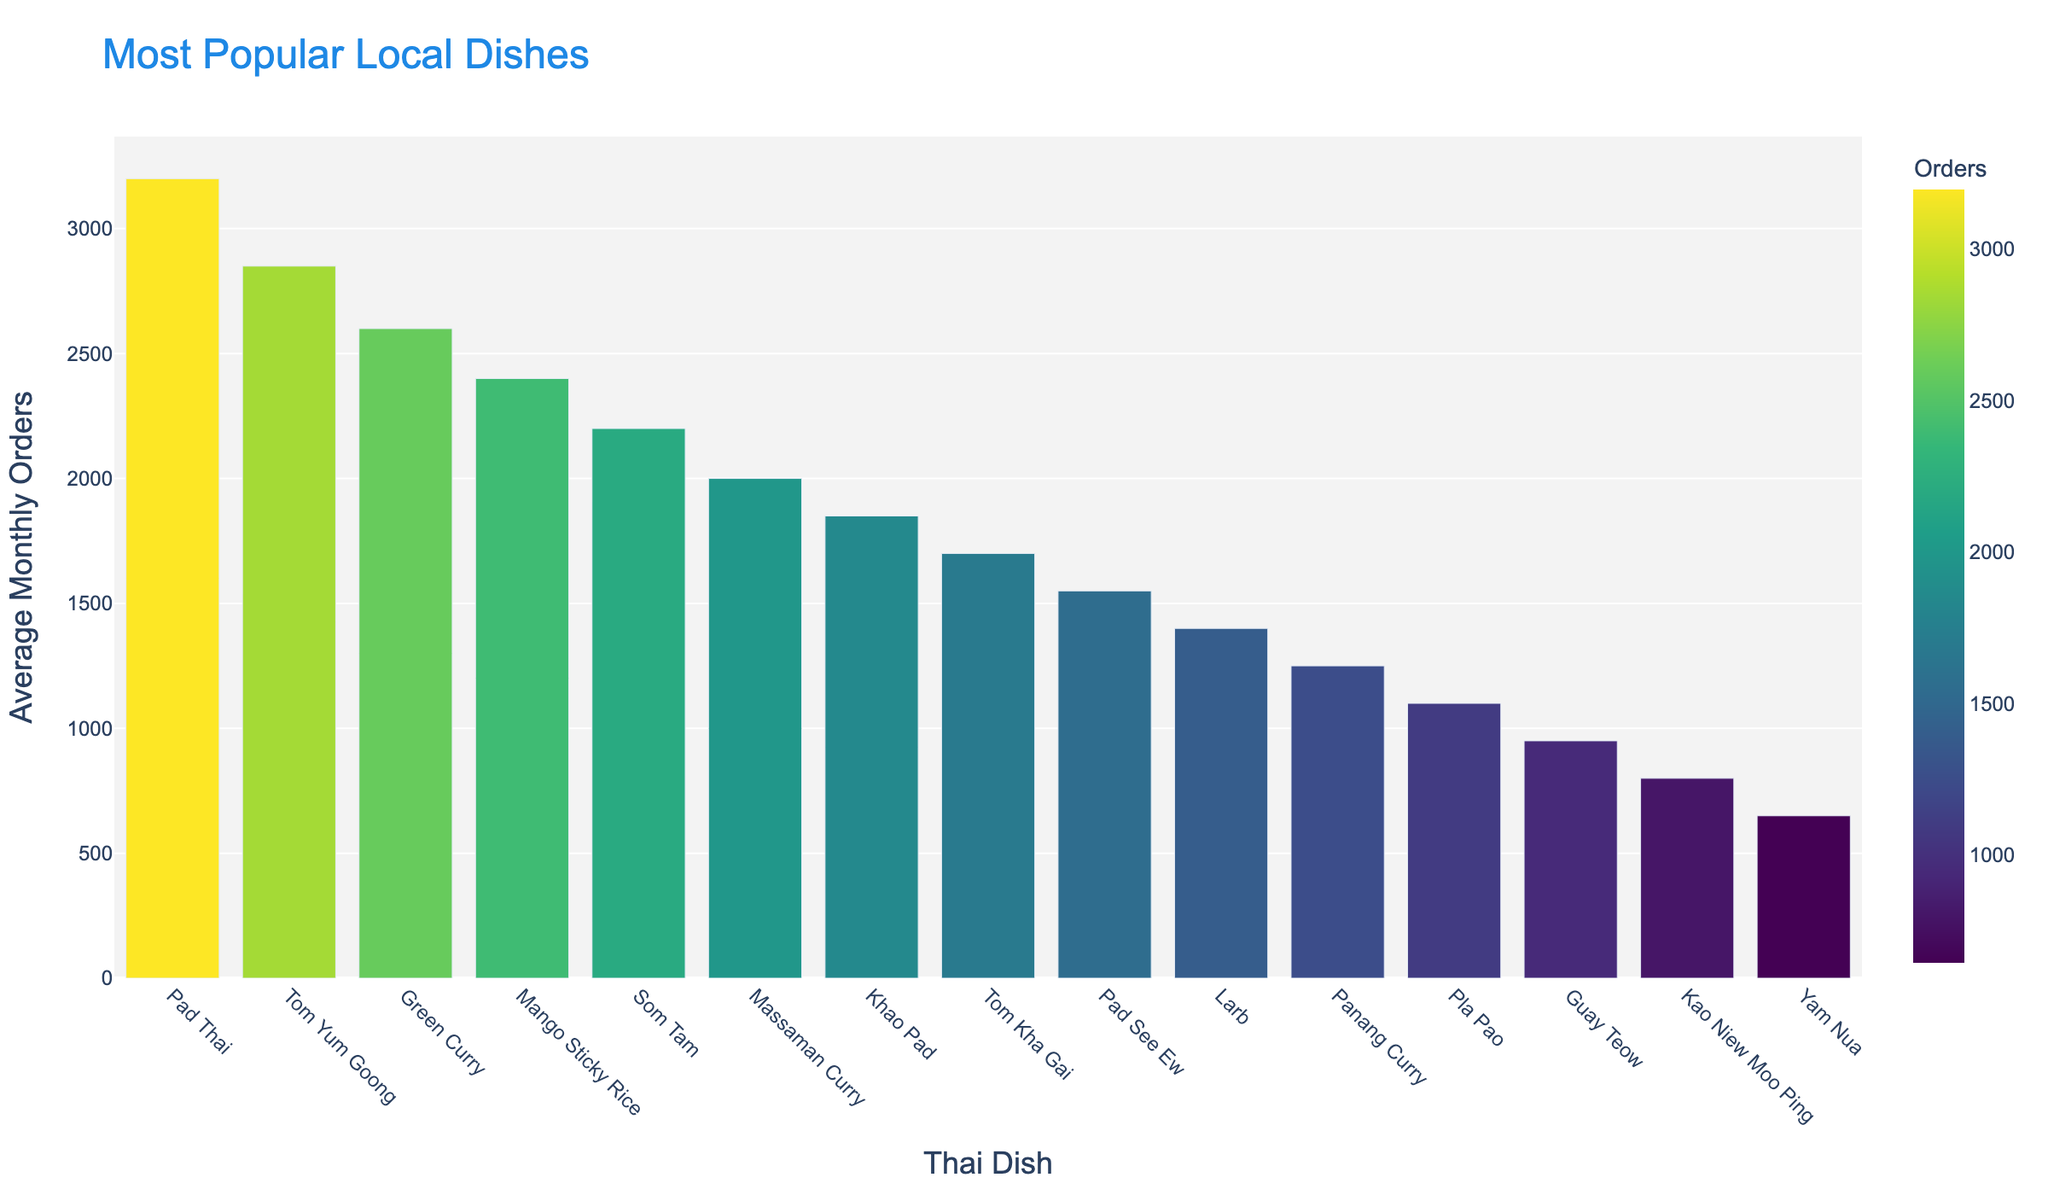What's the most popular local dish? The most popular dish will have the highest bar on the chart. Here, the tallest bar corresponds to Pad Thai.
Answer: Pad Thai How many more average orders per month does Tom Yum Goong have compared to Larb? Subtract Larb's average orders (1400) from Tom Yum Goong's average orders (2850). Calculation: 2850 - 1400
Answer: 1450 Which dish has the lowest number of average orders per month? The dish with the shortest bar represents the lowest number of average orders. Here, the shortest bar corresponds to Yam Nua.
Answer: Yam Nua How do the average orders of Green Curry and Mango Sticky Rice compare? Compare the heights of the bars for Green Curry (2600) and Mango Sticky Rice (2400). Green Curry has a higher number of average orders.
Answer: Green Curry is more popular What is the total number of average orders per month for the top three dishes? Add the average orders of Pad Thai (3200), Tom Yum Goong (2850), and Green Curry (2600). Calculation: 3200 + 2850 + 2600
Answer: 8650 What is the difference in average orders between the most and least popular dishes? Subtract the average orders of the least popular dish, Yam Nua (650), from the most popular dish, Pad Thai (3200). Calculation: 3200 - 650
Answer: 2550 Which color represents the dish with the fourth highest average orders? Locate the fourth highest bar, which is Mango Sticky Rice (2400), and note the color coding used in the chart.
Answer: Green (Viridis Scale) How many dishes have average orders greater than 2000? Count the number of bars with values above 2000: Pad Thai, Tom Yum Goong, Green Curry, Mango Sticky Rice, Som Tam, Massaman Curry.
Answer: 6 What is the sum of average orders for Khao Pad and Tom Kha Gai? Add the average orders of Khao Pad (1850) and Tom Kha Gai (1700). Calculation: 1850 + 1700
Answer: 3550 Compare the popularity of Panang Curry and Pad See Ew. Which one is more popular and by how much? Panang Curry has 1250 average orders, and Pad See Ew has 1550 average orders. Calculate the difference: 1550 – 1250
Answer: Pad See Ew by 300 